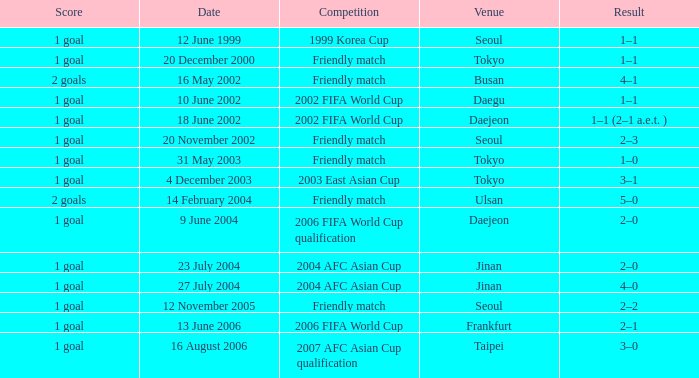What is the competition that occured on 27 July 2004? 2004 AFC Asian Cup. 